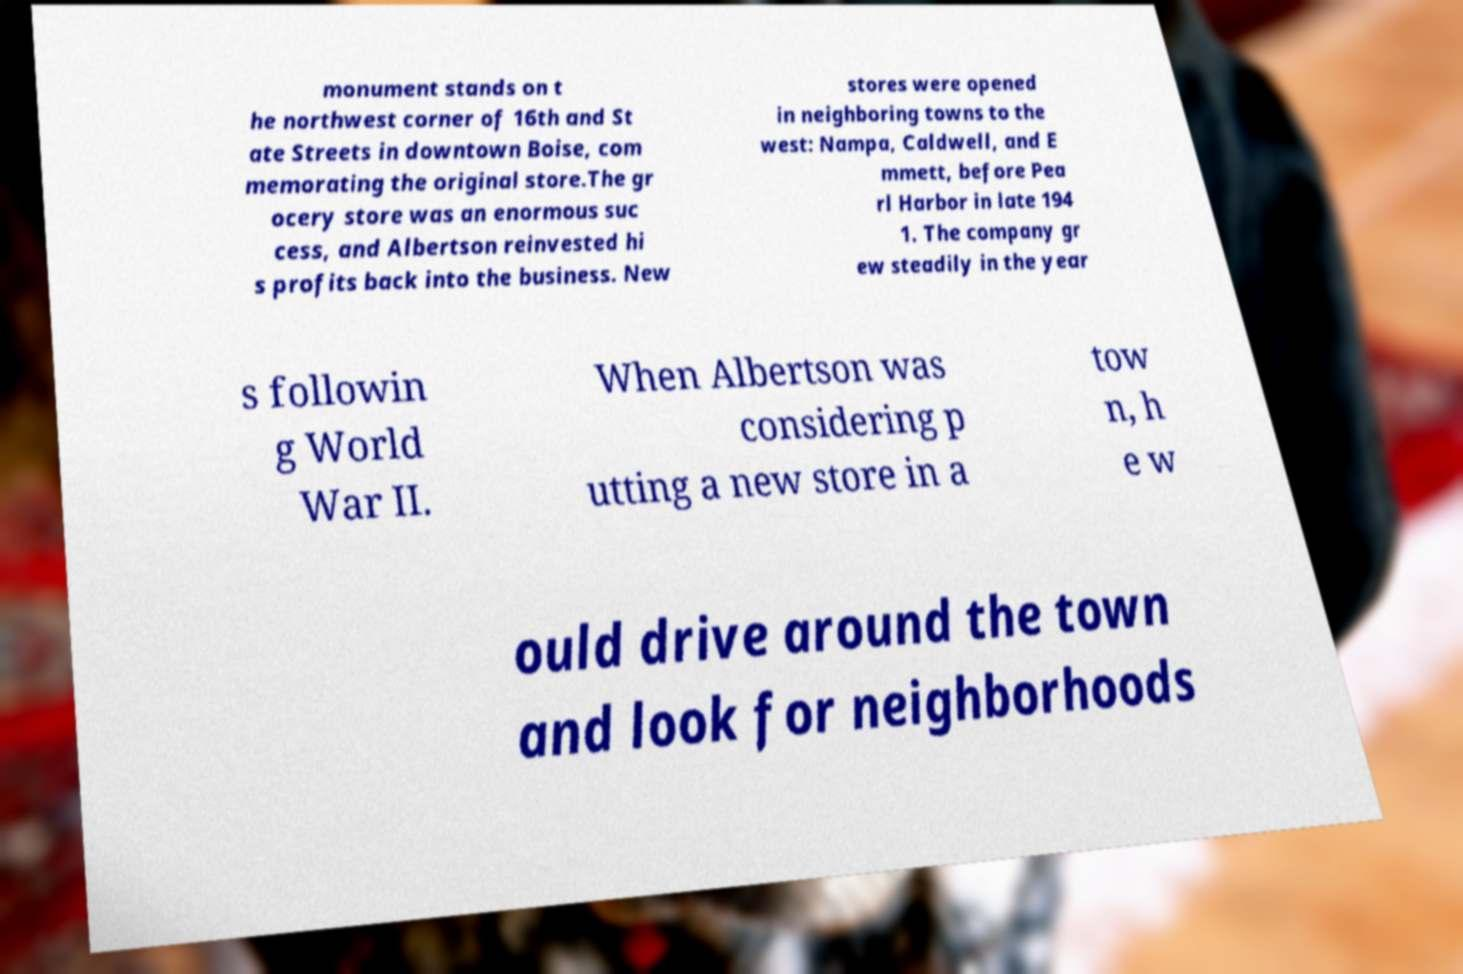Please identify and transcribe the text found in this image. monument stands on t he northwest corner of 16th and St ate Streets in downtown Boise, com memorating the original store.The gr ocery store was an enormous suc cess, and Albertson reinvested hi s profits back into the business. New stores were opened in neighboring towns to the west: Nampa, Caldwell, and E mmett, before Pea rl Harbor in late 194 1. The company gr ew steadily in the year s followin g World War II. When Albertson was considering p utting a new store in a tow n, h e w ould drive around the town and look for neighborhoods 